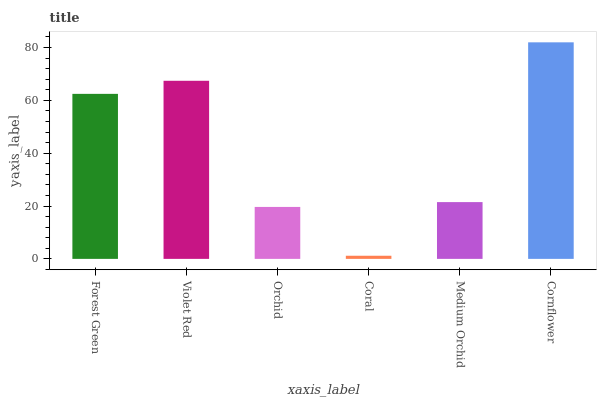Is Coral the minimum?
Answer yes or no. Yes. Is Cornflower the maximum?
Answer yes or no. Yes. Is Violet Red the minimum?
Answer yes or no. No. Is Violet Red the maximum?
Answer yes or no. No. Is Violet Red greater than Forest Green?
Answer yes or no. Yes. Is Forest Green less than Violet Red?
Answer yes or no. Yes. Is Forest Green greater than Violet Red?
Answer yes or no. No. Is Violet Red less than Forest Green?
Answer yes or no. No. Is Forest Green the high median?
Answer yes or no. Yes. Is Medium Orchid the low median?
Answer yes or no. Yes. Is Violet Red the high median?
Answer yes or no. No. Is Violet Red the low median?
Answer yes or no. No. 